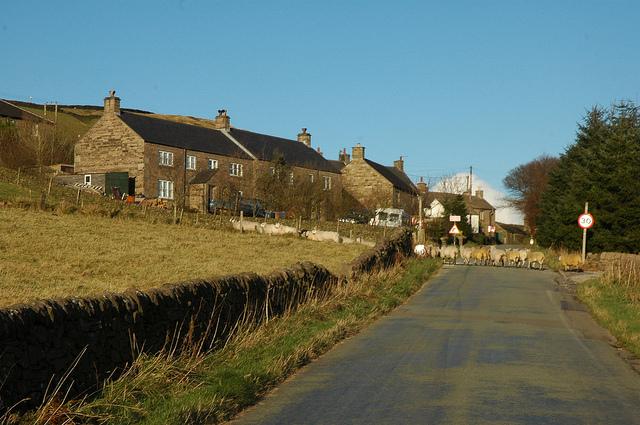Does the photo portray rural country lifestyle?
Keep it brief. Yes. What is this building made from?
Keep it brief. Stone. Are there animals?
Give a very brief answer. Yes. Sunny or overcast?
Give a very brief answer. Sunny. 